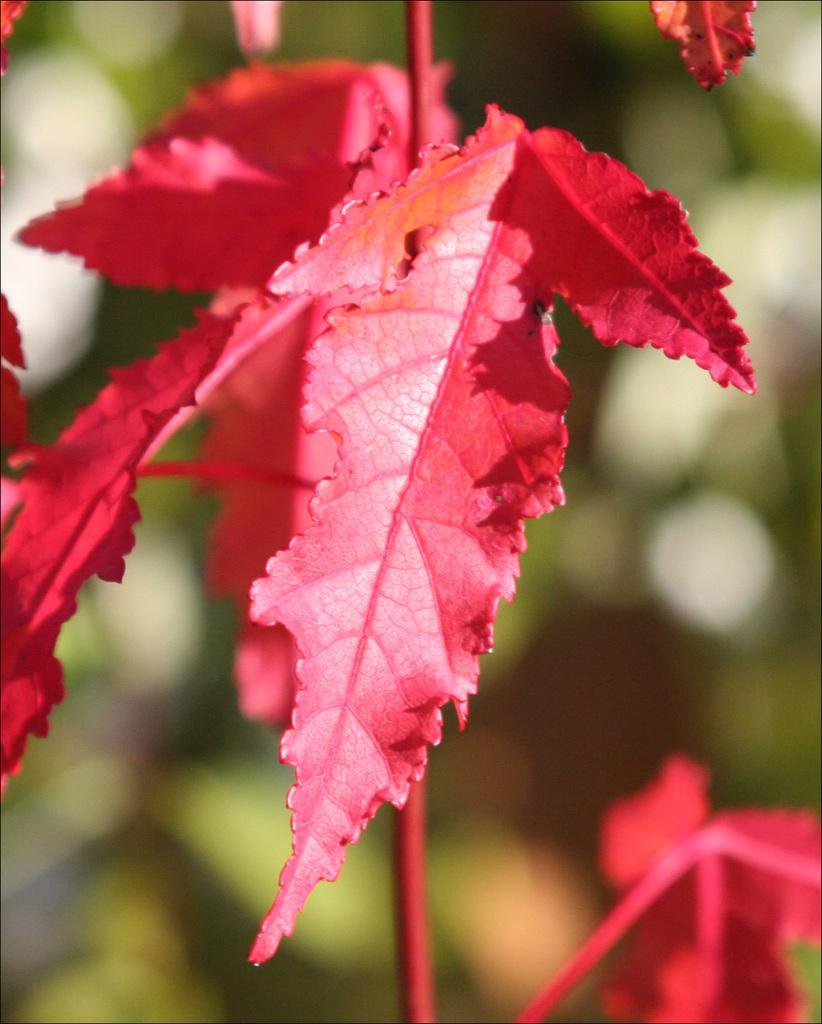Could you give a brief overview of what you see in this image? In this image there are red color leaves. The picture is blurry. I think, there are trees in the background. 